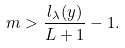<formula> <loc_0><loc_0><loc_500><loc_500>m > \frac { l _ { \lambda } ( y ) } { L + 1 } - 1 .</formula> 